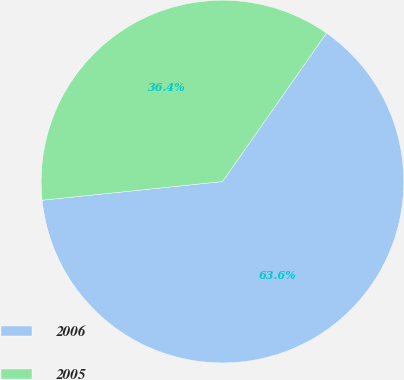<chart> <loc_0><loc_0><loc_500><loc_500><pie_chart><fcel>2006<fcel>2005<nl><fcel>63.64%<fcel>36.36%<nl></chart> 